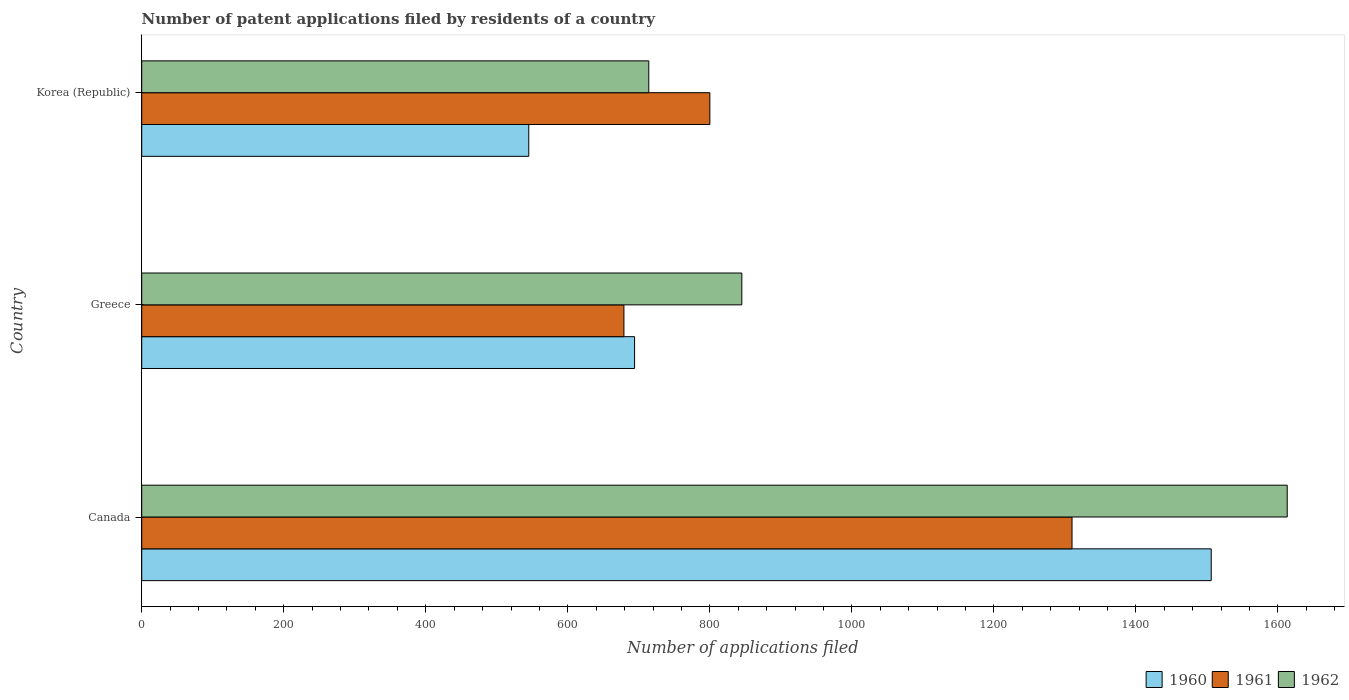How many different coloured bars are there?
Your answer should be compact. 3. How many groups of bars are there?
Your answer should be very brief. 3. Are the number of bars per tick equal to the number of legend labels?
Offer a terse response. Yes. How many bars are there on the 2nd tick from the bottom?
Your answer should be compact. 3. In how many cases, is the number of bars for a given country not equal to the number of legend labels?
Ensure brevity in your answer.  0. What is the number of applications filed in 1962 in Canada?
Your answer should be very brief. 1613. Across all countries, what is the maximum number of applications filed in 1962?
Offer a very short reply. 1613. Across all countries, what is the minimum number of applications filed in 1962?
Your response must be concise. 714. In which country was the number of applications filed in 1962 maximum?
Your answer should be compact. Canada. In which country was the number of applications filed in 1960 minimum?
Give a very brief answer. Korea (Republic). What is the total number of applications filed in 1962 in the graph?
Your answer should be very brief. 3172. What is the difference between the number of applications filed in 1960 in Canada and that in Korea (Republic)?
Provide a short and direct response. 961. What is the difference between the number of applications filed in 1960 in Greece and the number of applications filed in 1962 in Canada?
Your answer should be very brief. -919. What is the average number of applications filed in 1962 per country?
Give a very brief answer. 1057.33. In how many countries, is the number of applications filed in 1962 greater than 1360 ?
Make the answer very short. 1. What is the ratio of the number of applications filed in 1962 in Canada to that in Greece?
Your response must be concise. 1.91. What is the difference between the highest and the second highest number of applications filed in 1961?
Offer a very short reply. 510. What is the difference between the highest and the lowest number of applications filed in 1961?
Provide a succinct answer. 631. Is the sum of the number of applications filed in 1962 in Canada and Greece greater than the maximum number of applications filed in 1961 across all countries?
Offer a terse response. Yes. What does the 1st bar from the top in Canada represents?
Give a very brief answer. 1962. What does the 1st bar from the bottom in Canada represents?
Your answer should be compact. 1960. Are all the bars in the graph horizontal?
Your answer should be very brief. Yes. How many countries are there in the graph?
Make the answer very short. 3. What is the difference between two consecutive major ticks on the X-axis?
Offer a terse response. 200. Are the values on the major ticks of X-axis written in scientific E-notation?
Keep it short and to the point. No. What is the title of the graph?
Provide a short and direct response. Number of patent applications filed by residents of a country. Does "1971" appear as one of the legend labels in the graph?
Offer a terse response. No. What is the label or title of the X-axis?
Ensure brevity in your answer.  Number of applications filed. What is the Number of applications filed of 1960 in Canada?
Keep it short and to the point. 1506. What is the Number of applications filed in 1961 in Canada?
Your answer should be compact. 1310. What is the Number of applications filed in 1962 in Canada?
Ensure brevity in your answer.  1613. What is the Number of applications filed in 1960 in Greece?
Provide a short and direct response. 694. What is the Number of applications filed in 1961 in Greece?
Keep it short and to the point. 679. What is the Number of applications filed of 1962 in Greece?
Your answer should be very brief. 845. What is the Number of applications filed of 1960 in Korea (Republic)?
Offer a terse response. 545. What is the Number of applications filed of 1961 in Korea (Republic)?
Your answer should be very brief. 800. What is the Number of applications filed in 1962 in Korea (Republic)?
Offer a terse response. 714. Across all countries, what is the maximum Number of applications filed in 1960?
Offer a terse response. 1506. Across all countries, what is the maximum Number of applications filed of 1961?
Provide a succinct answer. 1310. Across all countries, what is the maximum Number of applications filed in 1962?
Your response must be concise. 1613. Across all countries, what is the minimum Number of applications filed of 1960?
Ensure brevity in your answer.  545. Across all countries, what is the minimum Number of applications filed of 1961?
Provide a short and direct response. 679. Across all countries, what is the minimum Number of applications filed in 1962?
Ensure brevity in your answer.  714. What is the total Number of applications filed of 1960 in the graph?
Make the answer very short. 2745. What is the total Number of applications filed of 1961 in the graph?
Provide a succinct answer. 2789. What is the total Number of applications filed of 1962 in the graph?
Offer a very short reply. 3172. What is the difference between the Number of applications filed of 1960 in Canada and that in Greece?
Ensure brevity in your answer.  812. What is the difference between the Number of applications filed in 1961 in Canada and that in Greece?
Your answer should be compact. 631. What is the difference between the Number of applications filed of 1962 in Canada and that in Greece?
Your response must be concise. 768. What is the difference between the Number of applications filed in 1960 in Canada and that in Korea (Republic)?
Offer a very short reply. 961. What is the difference between the Number of applications filed of 1961 in Canada and that in Korea (Republic)?
Keep it short and to the point. 510. What is the difference between the Number of applications filed of 1962 in Canada and that in Korea (Republic)?
Your answer should be compact. 899. What is the difference between the Number of applications filed of 1960 in Greece and that in Korea (Republic)?
Your response must be concise. 149. What is the difference between the Number of applications filed of 1961 in Greece and that in Korea (Republic)?
Give a very brief answer. -121. What is the difference between the Number of applications filed of 1962 in Greece and that in Korea (Republic)?
Ensure brevity in your answer.  131. What is the difference between the Number of applications filed of 1960 in Canada and the Number of applications filed of 1961 in Greece?
Your answer should be compact. 827. What is the difference between the Number of applications filed in 1960 in Canada and the Number of applications filed in 1962 in Greece?
Ensure brevity in your answer.  661. What is the difference between the Number of applications filed in 1961 in Canada and the Number of applications filed in 1962 in Greece?
Give a very brief answer. 465. What is the difference between the Number of applications filed of 1960 in Canada and the Number of applications filed of 1961 in Korea (Republic)?
Give a very brief answer. 706. What is the difference between the Number of applications filed of 1960 in Canada and the Number of applications filed of 1962 in Korea (Republic)?
Give a very brief answer. 792. What is the difference between the Number of applications filed of 1961 in Canada and the Number of applications filed of 1962 in Korea (Republic)?
Provide a succinct answer. 596. What is the difference between the Number of applications filed of 1960 in Greece and the Number of applications filed of 1961 in Korea (Republic)?
Offer a terse response. -106. What is the difference between the Number of applications filed of 1960 in Greece and the Number of applications filed of 1962 in Korea (Republic)?
Offer a very short reply. -20. What is the difference between the Number of applications filed in 1961 in Greece and the Number of applications filed in 1962 in Korea (Republic)?
Provide a short and direct response. -35. What is the average Number of applications filed of 1960 per country?
Offer a very short reply. 915. What is the average Number of applications filed in 1961 per country?
Provide a succinct answer. 929.67. What is the average Number of applications filed in 1962 per country?
Provide a succinct answer. 1057.33. What is the difference between the Number of applications filed in 1960 and Number of applications filed in 1961 in Canada?
Provide a succinct answer. 196. What is the difference between the Number of applications filed in 1960 and Number of applications filed in 1962 in Canada?
Your response must be concise. -107. What is the difference between the Number of applications filed in 1961 and Number of applications filed in 1962 in Canada?
Make the answer very short. -303. What is the difference between the Number of applications filed in 1960 and Number of applications filed in 1961 in Greece?
Make the answer very short. 15. What is the difference between the Number of applications filed of 1960 and Number of applications filed of 1962 in Greece?
Your answer should be very brief. -151. What is the difference between the Number of applications filed in 1961 and Number of applications filed in 1962 in Greece?
Offer a terse response. -166. What is the difference between the Number of applications filed of 1960 and Number of applications filed of 1961 in Korea (Republic)?
Provide a short and direct response. -255. What is the difference between the Number of applications filed in 1960 and Number of applications filed in 1962 in Korea (Republic)?
Your response must be concise. -169. What is the difference between the Number of applications filed in 1961 and Number of applications filed in 1962 in Korea (Republic)?
Your response must be concise. 86. What is the ratio of the Number of applications filed of 1960 in Canada to that in Greece?
Your answer should be very brief. 2.17. What is the ratio of the Number of applications filed in 1961 in Canada to that in Greece?
Give a very brief answer. 1.93. What is the ratio of the Number of applications filed in 1962 in Canada to that in Greece?
Keep it short and to the point. 1.91. What is the ratio of the Number of applications filed in 1960 in Canada to that in Korea (Republic)?
Your answer should be very brief. 2.76. What is the ratio of the Number of applications filed in 1961 in Canada to that in Korea (Republic)?
Offer a terse response. 1.64. What is the ratio of the Number of applications filed in 1962 in Canada to that in Korea (Republic)?
Keep it short and to the point. 2.26. What is the ratio of the Number of applications filed in 1960 in Greece to that in Korea (Republic)?
Provide a succinct answer. 1.27. What is the ratio of the Number of applications filed in 1961 in Greece to that in Korea (Republic)?
Offer a terse response. 0.85. What is the ratio of the Number of applications filed of 1962 in Greece to that in Korea (Republic)?
Give a very brief answer. 1.18. What is the difference between the highest and the second highest Number of applications filed in 1960?
Offer a terse response. 812. What is the difference between the highest and the second highest Number of applications filed in 1961?
Give a very brief answer. 510. What is the difference between the highest and the second highest Number of applications filed in 1962?
Offer a very short reply. 768. What is the difference between the highest and the lowest Number of applications filed of 1960?
Offer a very short reply. 961. What is the difference between the highest and the lowest Number of applications filed in 1961?
Offer a very short reply. 631. What is the difference between the highest and the lowest Number of applications filed in 1962?
Give a very brief answer. 899. 